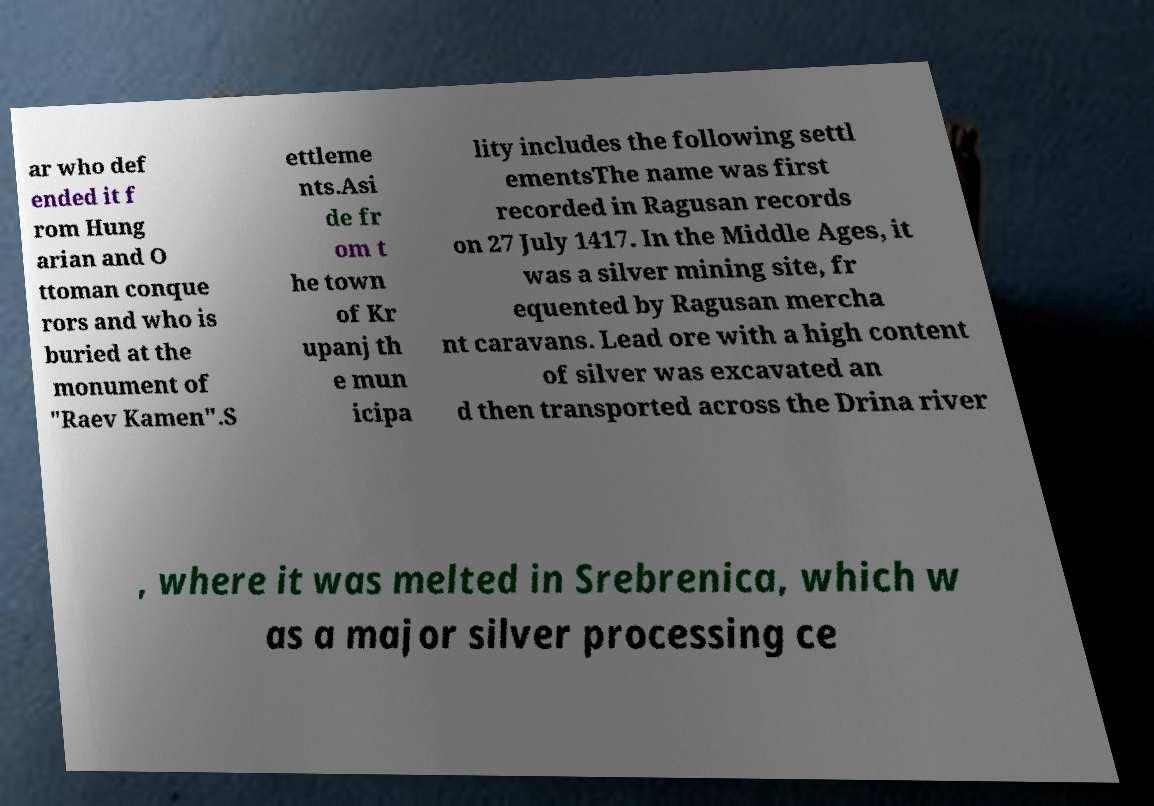Could you assist in decoding the text presented in this image and type it out clearly? ar who def ended it f rom Hung arian and O ttoman conque rors and who is buried at the monument of "Raev Kamen".S ettleme nts.Asi de fr om t he town of Kr upanj th e mun icipa lity includes the following settl ementsThe name was first recorded in Ragusan records on 27 July 1417. In the Middle Ages, it was a silver mining site, fr equented by Ragusan mercha nt caravans. Lead ore with a high content of silver was excavated an d then transported across the Drina river , where it was melted in Srebrenica, which w as a major silver processing ce 